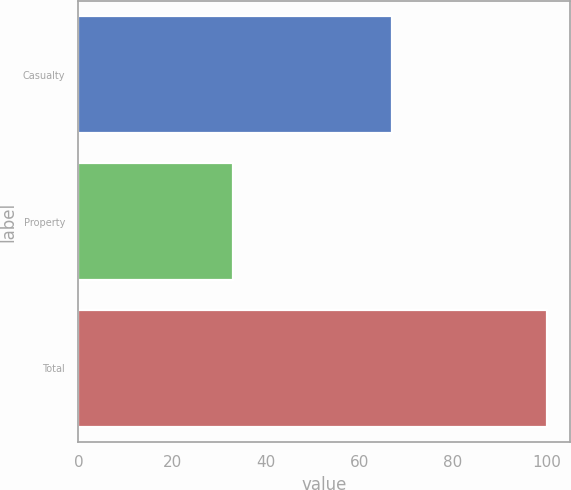Convert chart to OTSL. <chart><loc_0><loc_0><loc_500><loc_500><bar_chart><fcel>Casualty<fcel>Property<fcel>Total<nl><fcel>66.9<fcel>33.1<fcel>100<nl></chart> 